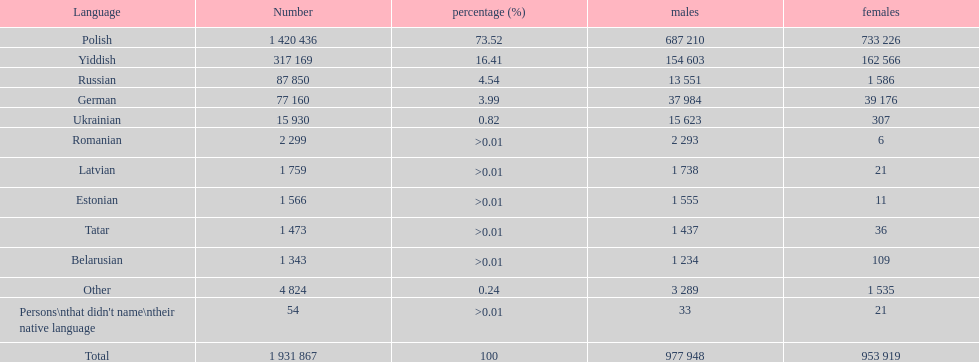Which languages can be heard in the warsaw governorate? Polish, Yiddish, Russian, German, Ukrainian, Romanian, Latvian, Estonian, Tatar, Belarusian, Other, Persons\nthat didn't name\ntheir native language. What is the figure for the russian language? 87 850. What is the next smallest number on this list? 77 160. Help me parse the entirety of this table. {'header': ['Language', 'Number', 'percentage (%)', 'males', 'females'], 'rows': [['Polish', '1 420 436', '73.52', '687 210', '733 226'], ['Yiddish', '317 169', '16.41', '154 603', '162 566'], ['Russian', '87 850', '4.54', '13 551', '1 586'], ['German', '77 160', '3.99', '37 984', '39 176'], ['Ukrainian', '15 930', '0.82', '15 623', '307'], ['Romanian', '2 299', '>0.01', '2 293', '6'], ['Latvian', '1 759', '>0.01', '1 738', '21'], ['Estonian', '1 566', '>0.01', '1 555', '11'], ['Tatar', '1 473', '>0.01', '1 437', '36'], ['Belarusian', '1 343', '>0.01', '1 234', '109'], ['Other', '4 824', '0.24', '3 289', '1 535'], ["Persons\\nthat didn't name\\ntheir native language", '54', '>0.01', '33', '21'], ['Total', '1 931 867', '100', '977 948', '953 919']]} Which language is spoken by 77,160 individuals? German. 